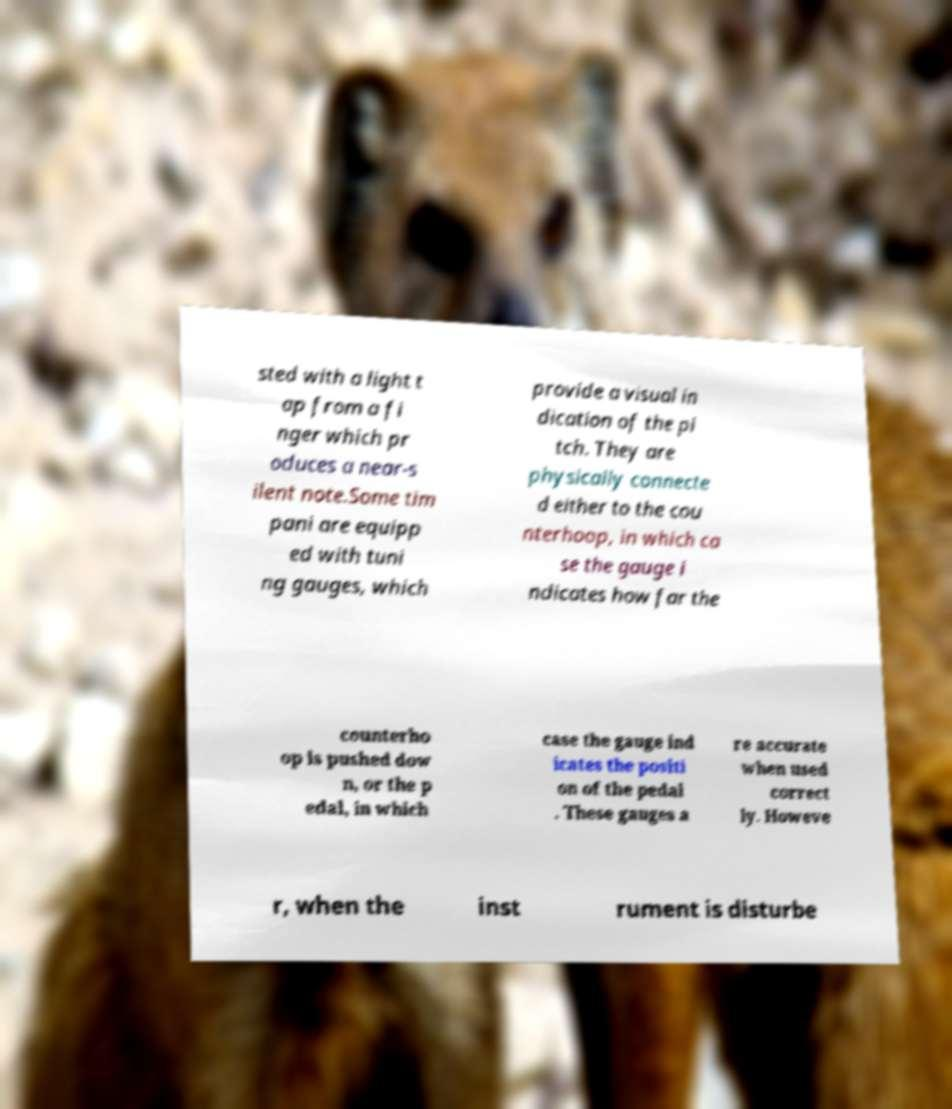There's text embedded in this image that I need extracted. Can you transcribe it verbatim? sted with a light t ap from a fi nger which pr oduces a near-s ilent note.Some tim pani are equipp ed with tuni ng gauges, which provide a visual in dication of the pi tch. They are physically connecte d either to the cou nterhoop, in which ca se the gauge i ndicates how far the counterho op is pushed dow n, or the p edal, in which case the gauge ind icates the positi on of the pedal . These gauges a re accurate when used correct ly. Howeve r, when the inst rument is disturbe 